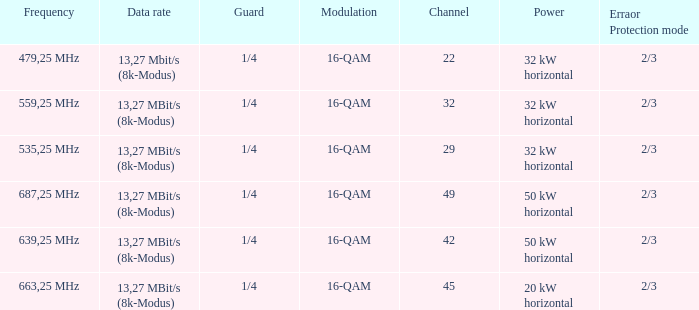On channel 32, when the power is 32 kW horizontal, what is the frequency? 559,25 MHz. 